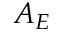<formula> <loc_0><loc_0><loc_500><loc_500>A _ { E }</formula> 